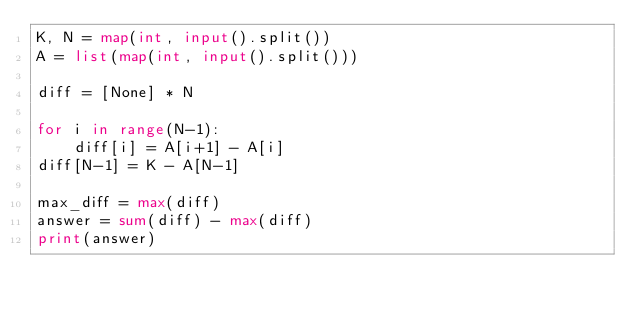Convert code to text. <code><loc_0><loc_0><loc_500><loc_500><_Python_>K, N = map(int, input().split())
A = list(map(int, input().split()))

diff = [None] * N

for i in range(N-1):
    diff[i] = A[i+1] - A[i]
diff[N-1] = K - A[N-1]

max_diff = max(diff)
answer = sum(diff) - max(diff)
print(answer)</code> 